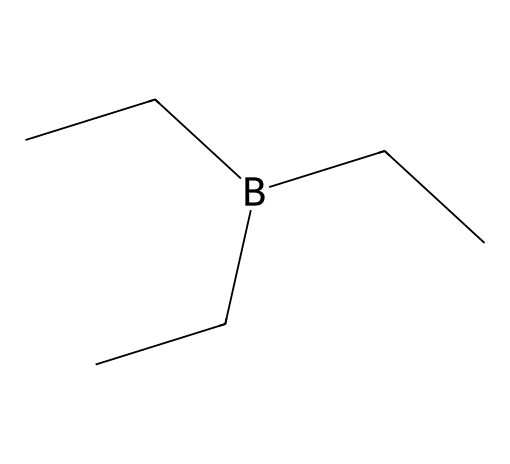What is the total number of carbon atoms in this compound? By analyzing the SMILES representation, I can identify that there are three ethyl groups (CC) attached to the boron atom. Each ethyl group consists of two carbon atoms, therefore, there are a total of 3 x 2 = 6 carbon atoms.
Answer: six How many hydrogen atoms are present in triethylborane? Each ethyl group (CC) contributes 5 hydrogen atoms (C2H5) and there are three ethyl groups. So, 3 x 5 = 15 hydrogen atoms.
Answer: fifteen What functional group is present in triethylborane? The structural representation indicates the presence of boron (B) bonded to alkyl groups, which characterizes this compound as a borane derivative. It specifically exemplifies trialkylboranes.
Answer: borane What is the molecular formula for triethylborane? Given the number of carbon, hydrogen, and boron atoms previously counted (6 carbon, 15 hydrogen, and 1 boron), I can derive the molecular formula C6H15B.
Answer: C6H15B Is triethylborane a polar or nonpolar compound? The compound predominantly consists of hydrocarbon chains (C and H), indicating nonpolar characteristics due to the lack of electronegative atoms leading to dipole moments.
Answer: nonpolar What type of reaction might triethylborane undergo in an aqueous environment? In an aqueous environment, triethylborane can undergo hydrolysis, reacting with water to produce boric acid (B(OH)3) and ethane (C2H6).
Answer: hydrolysis What is the primary industrial use of triethylborane? Triethylborane is primarily utilized as a reagent in organic synthesis and in the production of various boron compounds in industry.
Answer: reagent 